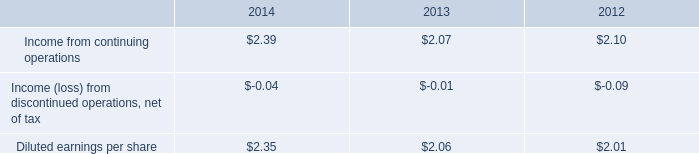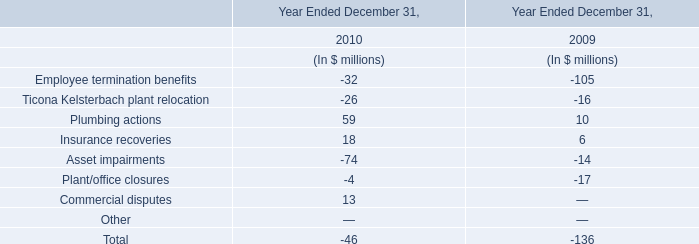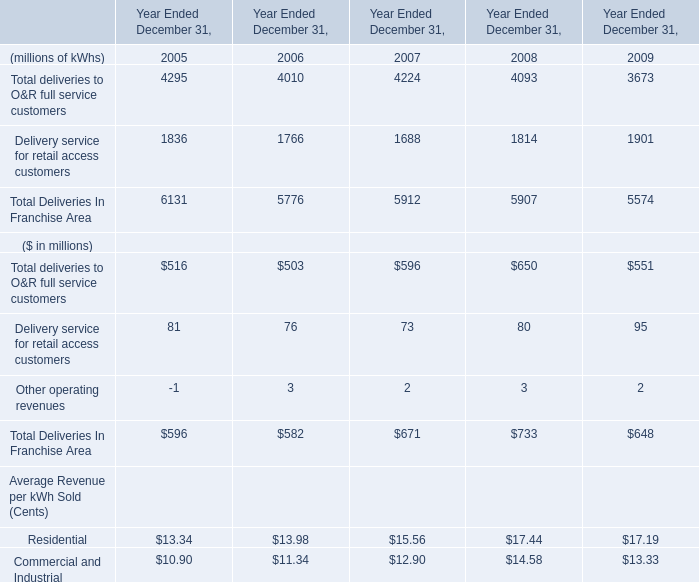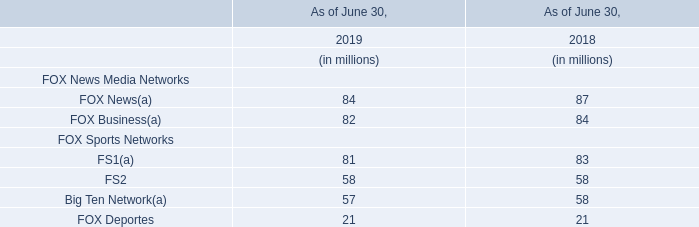What is the sum of Other operating revenues in 2008 and FOX Business in 2018? (in million) 
Computations: (3 + 84)
Answer: 87.0. 